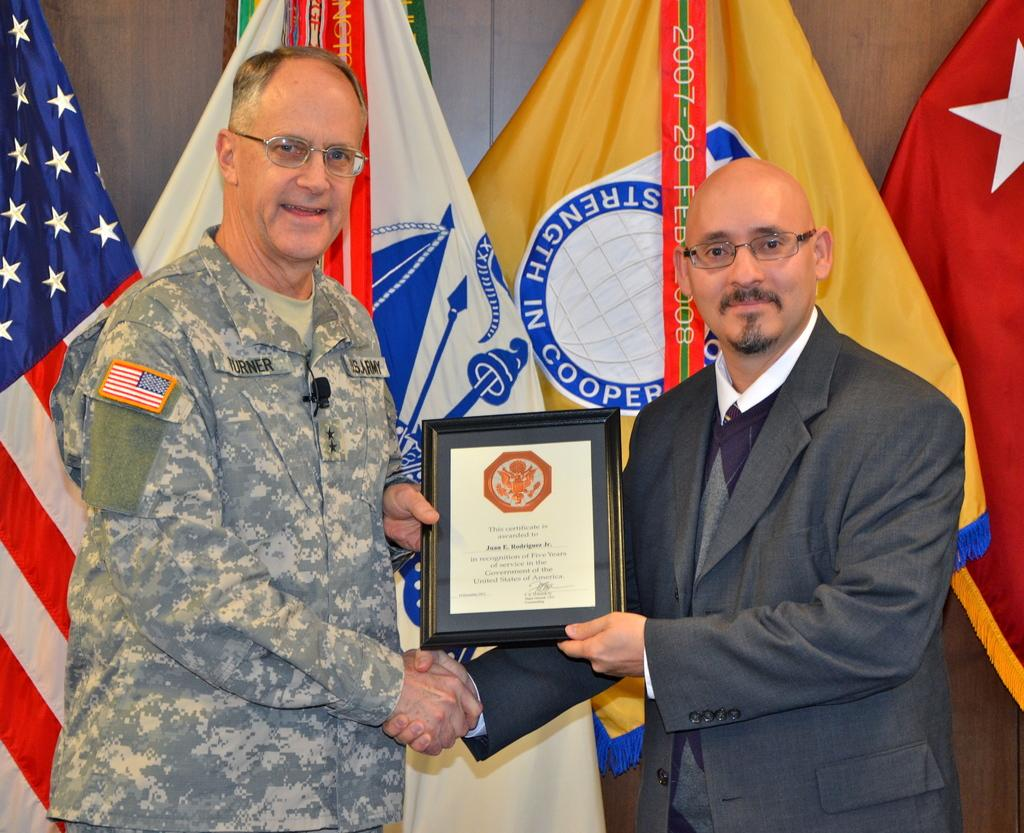How many people are in the image? There are two men in the image. What are the men wearing that is common to both of them? The men are wearing glasses (specs). What are the men holding in the image? The men are holding a momentum. What can be seen in the background of the image? There are flags of different countries in the background of the image. What type of egg is being used to represent the mind in the image? There is no egg or representation of the mind present in the image. 